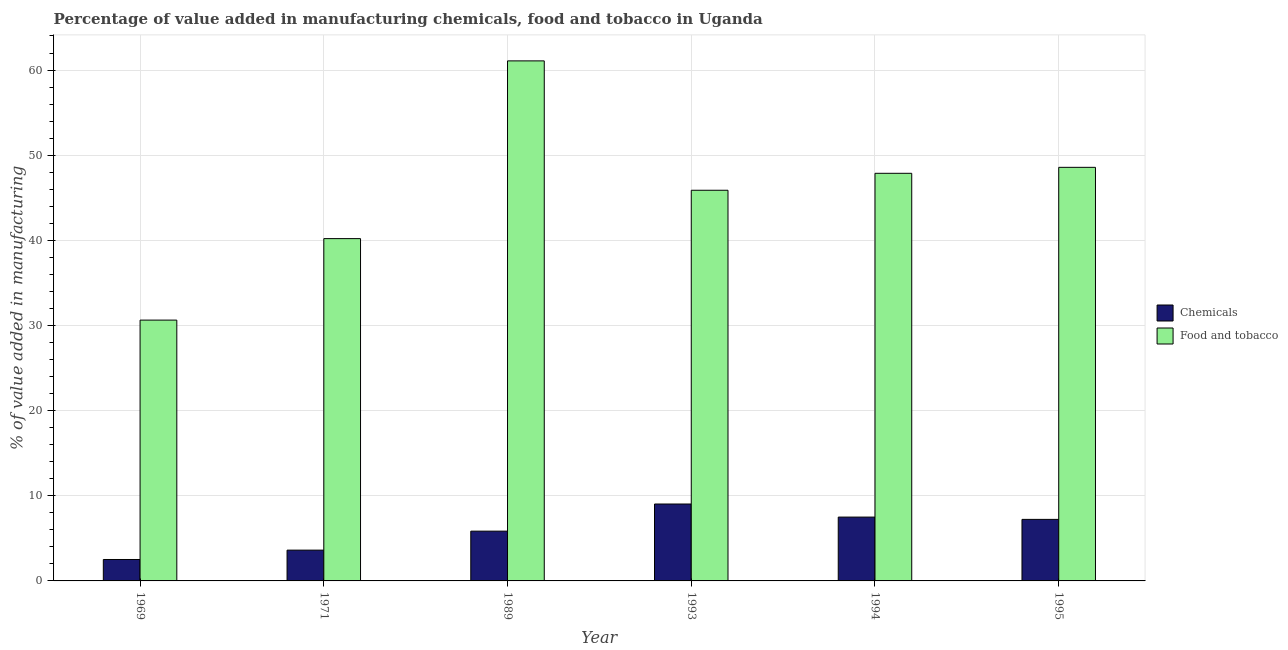How many bars are there on the 4th tick from the left?
Offer a very short reply. 2. How many bars are there on the 6th tick from the right?
Offer a terse response. 2. In how many cases, is the number of bars for a given year not equal to the number of legend labels?
Provide a succinct answer. 0. What is the value added by  manufacturing chemicals in 1993?
Your response must be concise. 9.03. Across all years, what is the maximum value added by  manufacturing chemicals?
Ensure brevity in your answer.  9.03. Across all years, what is the minimum value added by  manufacturing chemicals?
Provide a succinct answer. 2.52. In which year was the value added by manufacturing food and tobacco maximum?
Offer a terse response. 1989. In which year was the value added by  manufacturing chemicals minimum?
Offer a very short reply. 1969. What is the total value added by  manufacturing chemicals in the graph?
Make the answer very short. 35.73. What is the difference between the value added by manufacturing food and tobacco in 1969 and that in 1994?
Offer a very short reply. -17.24. What is the difference between the value added by manufacturing food and tobacco in 1971 and the value added by  manufacturing chemicals in 1995?
Make the answer very short. -8.37. What is the average value added by  manufacturing chemicals per year?
Make the answer very short. 5.96. In the year 1994, what is the difference between the value added by  manufacturing chemicals and value added by manufacturing food and tobacco?
Your answer should be compact. 0. In how many years, is the value added by  manufacturing chemicals greater than 32 %?
Ensure brevity in your answer.  0. What is the ratio of the value added by manufacturing food and tobacco in 1989 to that in 1994?
Your answer should be very brief. 1.28. Is the value added by manufacturing food and tobacco in 1971 less than that in 1993?
Your response must be concise. Yes. What is the difference between the highest and the second highest value added by manufacturing food and tobacco?
Make the answer very short. 12.5. What is the difference between the highest and the lowest value added by  manufacturing chemicals?
Provide a succinct answer. 6.52. What does the 1st bar from the left in 1969 represents?
Ensure brevity in your answer.  Chemicals. What does the 2nd bar from the right in 1995 represents?
Make the answer very short. Chemicals. How many bars are there?
Your answer should be compact. 12. Are all the bars in the graph horizontal?
Offer a terse response. No. How many years are there in the graph?
Your response must be concise. 6. Are the values on the major ticks of Y-axis written in scientific E-notation?
Offer a terse response. No. Does the graph contain any zero values?
Provide a succinct answer. No. Does the graph contain grids?
Make the answer very short. Yes. Where does the legend appear in the graph?
Your answer should be compact. Center right. How many legend labels are there?
Ensure brevity in your answer.  2. What is the title of the graph?
Provide a succinct answer. Percentage of value added in manufacturing chemicals, food and tobacco in Uganda. What is the label or title of the Y-axis?
Offer a very short reply. % of value added in manufacturing. What is the % of value added in manufacturing in Chemicals in 1969?
Offer a very short reply. 2.52. What is the % of value added in manufacturing in Food and tobacco in 1969?
Your answer should be compact. 30.63. What is the % of value added in manufacturing in Chemicals in 1971?
Your response must be concise. 3.62. What is the % of value added in manufacturing in Food and tobacco in 1971?
Give a very brief answer. 40.2. What is the % of value added in manufacturing in Chemicals in 1989?
Provide a short and direct response. 5.84. What is the % of value added in manufacturing of Food and tobacco in 1989?
Offer a terse response. 61.08. What is the % of value added in manufacturing in Chemicals in 1993?
Give a very brief answer. 9.03. What is the % of value added in manufacturing in Food and tobacco in 1993?
Keep it short and to the point. 45.88. What is the % of value added in manufacturing of Chemicals in 1994?
Provide a succinct answer. 7.5. What is the % of value added in manufacturing of Food and tobacco in 1994?
Offer a terse response. 47.87. What is the % of value added in manufacturing of Chemicals in 1995?
Make the answer very short. 7.23. What is the % of value added in manufacturing of Food and tobacco in 1995?
Provide a succinct answer. 48.57. Across all years, what is the maximum % of value added in manufacturing of Chemicals?
Give a very brief answer. 9.03. Across all years, what is the maximum % of value added in manufacturing of Food and tobacco?
Your answer should be very brief. 61.08. Across all years, what is the minimum % of value added in manufacturing in Chemicals?
Offer a terse response. 2.52. Across all years, what is the minimum % of value added in manufacturing of Food and tobacco?
Your answer should be compact. 30.63. What is the total % of value added in manufacturing in Chemicals in the graph?
Your answer should be very brief. 35.73. What is the total % of value added in manufacturing of Food and tobacco in the graph?
Your answer should be compact. 274.24. What is the difference between the % of value added in manufacturing of Chemicals in 1969 and that in 1971?
Your answer should be very brief. -1.1. What is the difference between the % of value added in manufacturing of Food and tobacco in 1969 and that in 1971?
Make the answer very short. -9.57. What is the difference between the % of value added in manufacturing of Chemicals in 1969 and that in 1989?
Your answer should be very brief. -3.33. What is the difference between the % of value added in manufacturing in Food and tobacco in 1969 and that in 1989?
Make the answer very short. -30.44. What is the difference between the % of value added in manufacturing of Chemicals in 1969 and that in 1993?
Offer a terse response. -6.52. What is the difference between the % of value added in manufacturing of Food and tobacco in 1969 and that in 1993?
Make the answer very short. -15.25. What is the difference between the % of value added in manufacturing in Chemicals in 1969 and that in 1994?
Ensure brevity in your answer.  -4.98. What is the difference between the % of value added in manufacturing of Food and tobacco in 1969 and that in 1994?
Your answer should be compact. -17.24. What is the difference between the % of value added in manufacturing of Chemicals in 1969 and that in 1995?
Offer a terse response. -4.71. What is the difference between the % of value added in manufacturing of Food and tobacco in 1969 and that in 1995?
Keep it short and to the point. -17.94. What is the difference between the % of value added in manufacturing in Chemicals in 1971 and that in 1989?
Your answer should be very brief. -2.23. What is the difference between the % of value added in manufacturing of Food and tobacco in 1971 and that in 1989?
Your answer should be compact. -20.88. What is the difference between the % of value added in manufacturing in Chemicals in 1971 and that in 1993?
Offer a very short reply. -5.42. What is the difference between the % of value added in manufacturing in Food and tobacco in 1971 and that in 1993?
Your response must be concise. -5.68. What is the difference between the % of value added in manufacturing in Chemicals in 1971 and that in 1994?
Offer a terse response. -3.88. What is the difference between the % of value added in manufacturing of Food and tobacco in 1971 and that in 1994?
Provide a short and direct response. -7.67. What is the difference between the % of value added in manufacturing in Chemicals in 1971 and that in 1995?
Provide a short and direct response. -3.61. What is the difference between the % of value added in manufacturing in Food and tobacco in 1971 and that in 1995?
Offer a terse response. -8.37. What is the difference between the % of value added in manufacturing of Chemicals in 1989 and that in 1993?
Give a very brief answer. -3.19. What is the difference between the % of value added in manufacturing in Food and tobacco in 1989 and that in 1993?
Offer a very short reply. 15.2. What is the difference between the % of value added in manufacturing of Chemicals in 1989 and that in 1994?
Provide a succinct answer. -1.65. What is the difference between the % of value added in manufacturing of Food and tobacco in 1989 and that in 1994?
Provide a succinct answer. 13.2. What is the difference between the % of value added in manufacturing in Chemicals in 1989 and that in 1995?
Offer a very short reply. -1.38. What is the difference between the % of value added in manufacturing of Food and tobacco in 1989 and that in 1995?
Ensure brevity in your answer.  12.5. What is the difference between the % of value added in manufacturing in Chemicals in 1993 and that in 1994?
Give a very brief answer. 1.54. What is the difference between the % of value added in manufacturing of Food and tobacco in 1993 and that in 1994?
Your answer should be compact. -1.99. What is the difference between the % of value added in manufacturing in Chemicals in 1993 and that in 1995?
Make the answer very short. 1.81. What is the difference between the % of value added in manufacturing of Food and tobacco in 1993 and that in 1995?
Make the answer very short. -2.69. What is the difference between the % of value added in manufacturing of Chemicals in 1994 and that in 1995?
Provide a succinct answer. 0.27. What is the difference between the % of value added in manufacturing in Food and tobacco in 1994 and that in 1995?
Ensure brevity in your answer.  -0.7. What is the difference between the % of value added in manufacturing of Chemicals in 1969 and the % of value added in manufacturing of Food and tobacco in 1971?
Make the answer very short. -37.69. What is the difference between the % of value added in manufacturing in Chemicals in 1969 and the % of value added in manufacturing in Food and tobacco in 1989?
Ensure brevity in your answer.  -58.56. What is the difference between the % of value added in manufacturing of Chemicals in 1969 and the % of value added in manufacturing of Food and tobacco in 1993?
Keep it short and to the point. -43.37. What is the difference between the % of value added in manufacturing in Chemicals in 1969 and the % of value added in manufacturing in Food and tobacco in 1994?
Your response must be concise. -45.36. What is the difference between the % of value added in manufacturing of Chemicals in 1969 and the % of value added in manufacturing of Food and tobacco in 1995?
Offer a very short reply. -46.06. What is the difference between the % of value added in manufacturing in Chemicals in 1971 and the % of value added in manufacturing in Food and tobacco in 1989?
Your answer should be very brief. -57.46. What is the difference between the % of value added in manufacturing in Chemicals in 1971 and the % of value added in manufacturing in Food and tobacco in 1993?
Your answer should be compact. -42.26. What is the difference between the % of value added in manufacturing in Chemicals in 1971 and the % of value added in manufacturing in Food and tobacco in 1994?
Your response must be concise. -44.26. What is the difference between the % of value added in manufacturing in Chemicals in 1971 and the % of value added in manufacturing in Food and tobacco in 1995?
Offer a terse response. -44.96. What is the difference between the % of value added in manufacturing in Chemicals in 1989 and the % of value added in manufacturing in Food and tobacco in 1993?
Ensure brevity in your answer.  -40.04. What is the difference between the % of value added in manufacturing in Chemicals in 1989 and the % of value added in manufacturing in Food and tobacco in 1994?
Your answer should be compact. -42.03. What is the difference between the % of value added in manufacturing in Chemicals in 1989 and the % of value added in manufacturing in Food and tobacco in 1995?
Offer a very short reply. -42.73. What is the difference between the % of value added in manufacturing of Chemicals in 1993 and the % of value added in manufacturing of Food and tobacco in 1994?
Provide a short and direct response. -38.84. What is the difference between the % of value added in manufacturing in Chemicals in 1993 and the % of value added in manufacturing in Food and tobacco in 1995?
Make the answer very short. -39.54. What is the difference between the % of value added in manufacturing of Chemicals in 1994 and the % of value added in manufacturing of Food and tobacco in 1995?
Keep it short and to the point. -41.08. What is the average % of value added in manufacturing in Chemicals per year?
Make the answer very short. 5.96. What is the average % of value added in manufacturing in Food and tobacco per year?
Your answer should be compact. 45.71. In the year 1969, what is the difference between the % of value added in manufacturing of Chemicals and % of value added in manufacturing of Food and tobacco?
Your answer should be compact. -28.12. In the year 1971, what is the difference between the % of value added in manufacturing in Chemicals and % of value added in manufacturing in Food and tobacco?
Provide a succinct answer. -36.59. In the year 1989, what is the difference between the % of value added in manufacturing in Chemicals and % of value added in manufacturing in Food and tobacco?
Offer a very short reply. -55.23. In the year 1993, what is the difference between the % of value added in manufacturing of Chemicals and % of value added in manufacturing of Food and tobacco?
Offer a very short reply. -36.85. In the year 1994, what is the difference between the % of value added in manufacturing in Chemicals and % of value added in manufacturing in Food and tobacco?
Your response must be concise. -40.38. In the year 1995, what is the difference between the % of value added in manufacturing of Chemicals and % of value added in manufacturing of Food and tobacco?
Your response must be concise. -41.35. What is the ratio of the % of value added in manufacturing of Chemicals in 1969 to that in 1971?
Provide a succinct answer. 0.7. What is the ratio of the % of value added in manufacturing in Food and tobacco in 1969 to that in 1971?
Your answer should be compact. 0.76. What is the ratio of the % of value added in manufacturing of Chemicals in 1969 to that in 1989?
Ensure brevity in your answer.  0.43. What is the ratio of the % of value added in manufacturing of Food and tobacco in 1969 to that in 1989?
Your response must be concise. 0.5. What is the ratio of the % of value added in manufacturing in Chemicals in 1969 to that in 1993?
Offer a terse response. 0.28. What is the ratio of the % of value added in manufacturing in Food and tobacco in 1969 to that in 1993?
Offer a terse response. 0.67. What is the ratio of the % of value added in manufacturing of Chemicals in 1969 to that in 1994?
Your answer should be very brief. 0.34. What is the ratio of the % of value added in manufacturing in Food and tobacco in 1969 to that in 1994?
Ensure brevity in your answer.  0.64. What is the ratio of the % of value added in manufacturing in Chemicals in 1969 to that in 1995?
Ensure brevity in your answer.  0.35. What is the ratio of the % of value added in manufacturing of Food and tobacco in 1969 to that in 1995?
Keep it short and to the point. 0.63. What is the ratio of the % of value added in manufacturing in Chemicals in 1971 to that in 1989?
Your response must be concise. 0.62. What is the ratio of the % of value added in manufacturing of Food and tobacco in 1971 to that in 1989?
Your answer should be compact. 0.66. What is the ratio of the % of value added in manufacturing in Chemicals in 1971 to that in 1993?
Provide a succinct answer. 0.4. What is the ratio of the % of value added in manufacturing in Food and tobacco in 1971 to that in 1993?
Provide a short and direct response. 0.88. What is the ratio of the % of value added in manufacturing of Chemicals in 1971 to that in 1994?
Give a very brief answer. 0.48. What is the ratio of the % of value added in manufacturing of Food and tobacco in 1971 to that in 1994?
Keep it short and to the point. 0.84. What is the ratio of the % of value added in manufacturing of Chemicals in 1971 to that in 1995?
Offer a terse response. 0.5. What is the ratio of the % of value added in manufacturing in Food and tobacco in 1971 to that in 1995?
Your response must be concise. 0.83. What is the ratio of the % of value added in manufacturing in Chemicals in 1989 to that in 1993?
Ensure brevity in your answer.  0.65. What is the ratio of the % of value added in manufacturing in Food and tobacco in 1989 to that in 1993?
Keep it short and to the point. 1.33. What is the ratio of the % of value added in manufacturing of Chemicals in 1989 to that in 1994?
Offer a very short reply. 0.78. What is the ratio of the % of value added in manufacturing of Food and tobacco in 1989 to that in 1994?
Provide a short and direct response. 1.28. What is the ratio of the % of value added in manufacturing in Chemicals in 1989 to that in 1995?
Your response must be concise. 0.81. What is the ratio of the % of value added in manufacturing in Food and tobacco in 1989 to that in 1995?
Make the answer very short. 1.26. What is the ratio of the % of value added in manufacturing of Chemicals in 1993 to that in 1994?
Ensure brevity in your answer.  1.21. What is the ratio of the % of value added in manufacturing in Food and tobacco in 1993 to that in 1994?
Keep it short and to the point. 0.96. What is the ratio of the % of value added in manufacturing of Food and tobacco in 1993 to that in 1995?
Keep it short and to the point. 0.94. What is the ratio of the % of value added in manufacturing in Chemicals in 1994 to that in 1995?
Ensure brevity in your answer.  1.04. What is the ratio of the % of value added in manufacturing of Food and tobacco in 1994 to that in 1995?
Provide a succinct answer. 0.99. What is the difference between the highest and the second highest % of value added in manufacturing in Chemicals?
Your response must be concise. 1.54. What is the difference between the highest and the second highest % of value added in manufacturing in Food and tobacco?
Provide a short and direct response. 12.5. What is the difference between the highest and the lowest % of value added in manufacturing of Chemicals?
Provide a short and direct response. 6.52. What is the difference between the highest and the lowest % of value added in manufacturing of Food and tobacco?
Provide a succinct answer. 30.44. 